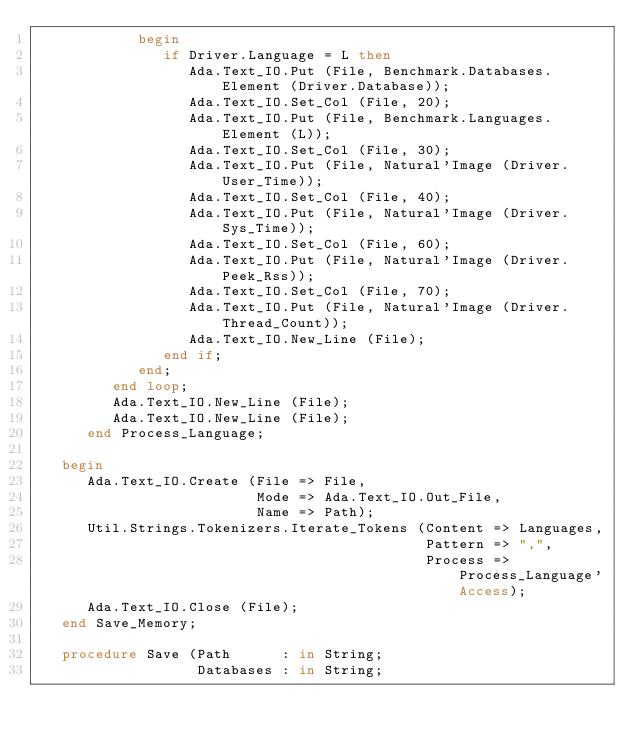Convert code to text. <code><loc_0><loc_0><loc_500><loc_500><_Ada_>            begin
               if Driver.Language = L then
                  Ada.Text_IO.Put (File, Benchmark.Databases.Element (Driver.Database));
                  Ada.Text_IO.Set_Col (File, 20);
                  Ada.Text_IO.Put (File, Benchmark.Languages.Element (L));
                  Ada.Text_IO.Set_Col (File, 30);
                  Ada.Text_IO.Put (File, Natural'Image (Driver.User_Time));
                  Ada.Text_IO.Set_Col (File, 40);
                  Ada.Text_IO.Put (File, Natural'Image (Driver.Sys_Time));
                  Ada.Text_IO.Set_Col (File, 60);
                  Ada.Text_IO.Put (File, Natural'Image (Driver.Peek_Rss));
                  Ada.Text_IO.Set_Col (File, 70);
                  Ada.Text_IO.Put (File, Natural'Image (Driver.Thread_Count));
                  Ada.Text_IO.New_Line (File);
               end if;
            end;
         end loop;
         Ada.Text_IO.New_Line (File);
         Ada.Text_IO.New_Line (File);
      end Process_Language;

   begin
      Ada.Text_IO.Create (File => File,
                          Mode => Ada.Text_IO.Out_File,
                          Name => Path);
      Util.Strings.Tokenizers.Iterate_Tokens (Content => Languages,
                                              Pattern => ",",
                                              Process => Process_Language'Access);
      Ada.Text_IO.Close (File);
   end Save_Memory;

   procedure Save (Path      : in String;
                   Databases : in String;</code> 